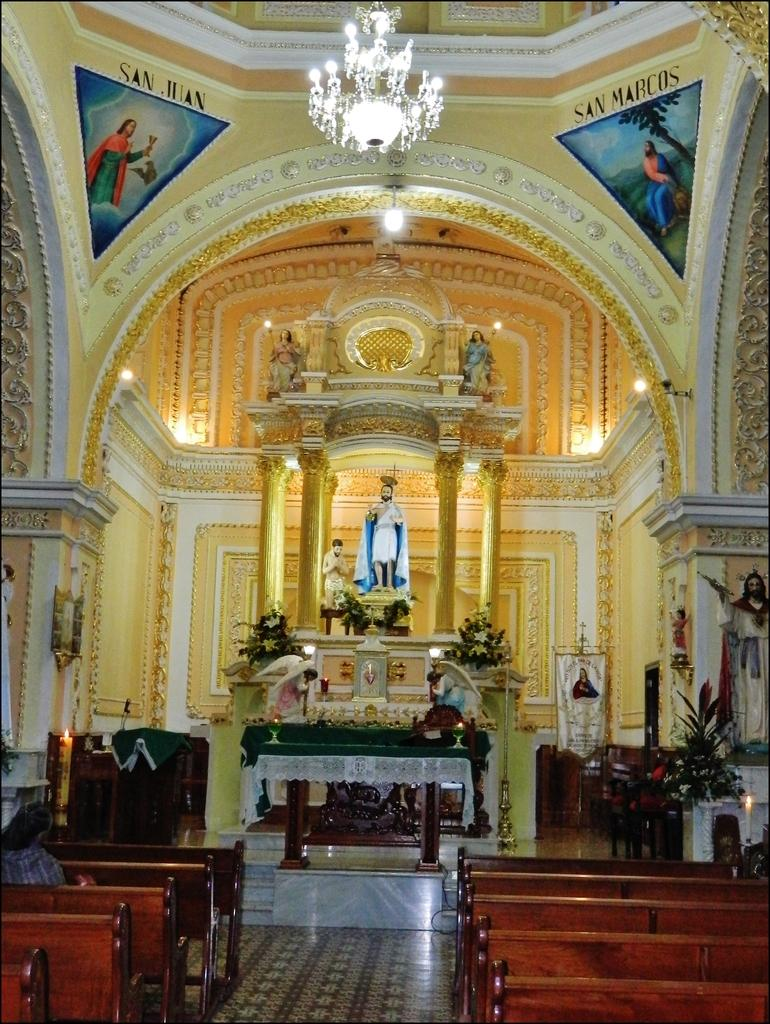What type of seating is available in the image? There are benches in the image. Can you describe the person's position in the image? There is a person sitting in the image. What kind of artwork is present in the image? There is a statue in the image. What type of furniture is visible in the image? There are tables in the image. What kind of greenery is present in the image? There are plants in the image. What type of decorative items are present in the image? There are banners in the image. What type of lighting fixture is present in the image? There is a chandelier in the image. What type of food is being served in the image? There is no food present in the image. What type of mineral is visible in the image? There is no quartz present in the image. 